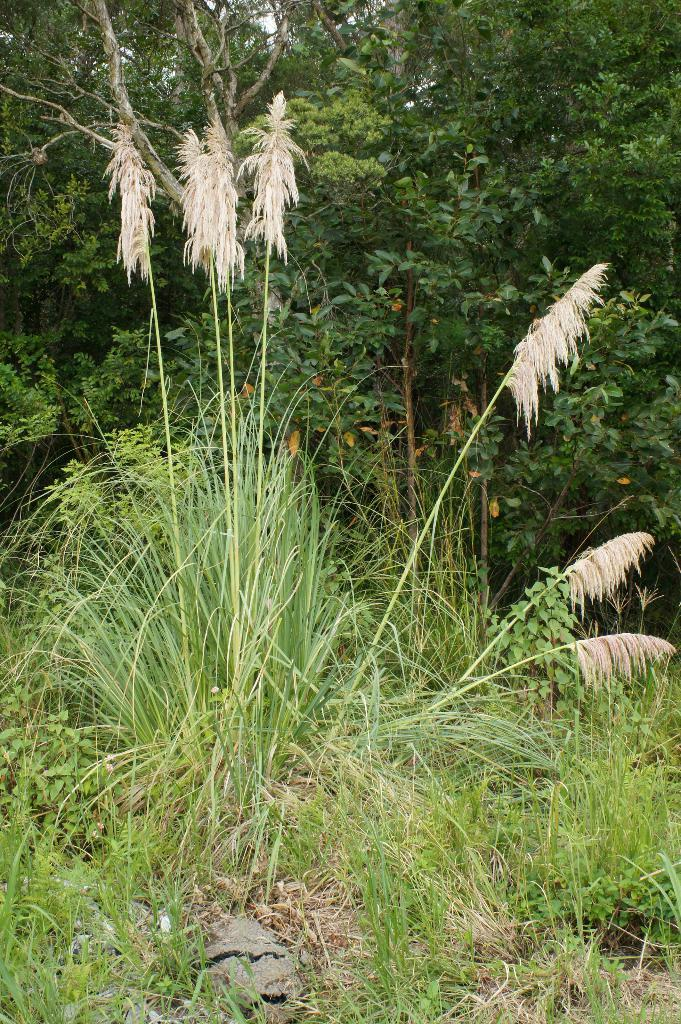What type of vegetation is at the bottom of the image? There is grass at the bottom of the image. What can be seen in the background of the image? There are trees in the background of the image. What type of cheese is present in the image? There is no cheese present in the image. What type of harmony is depicted in the image? The image does not depict any harmony; it features grass at the bottom and trees in the background. 